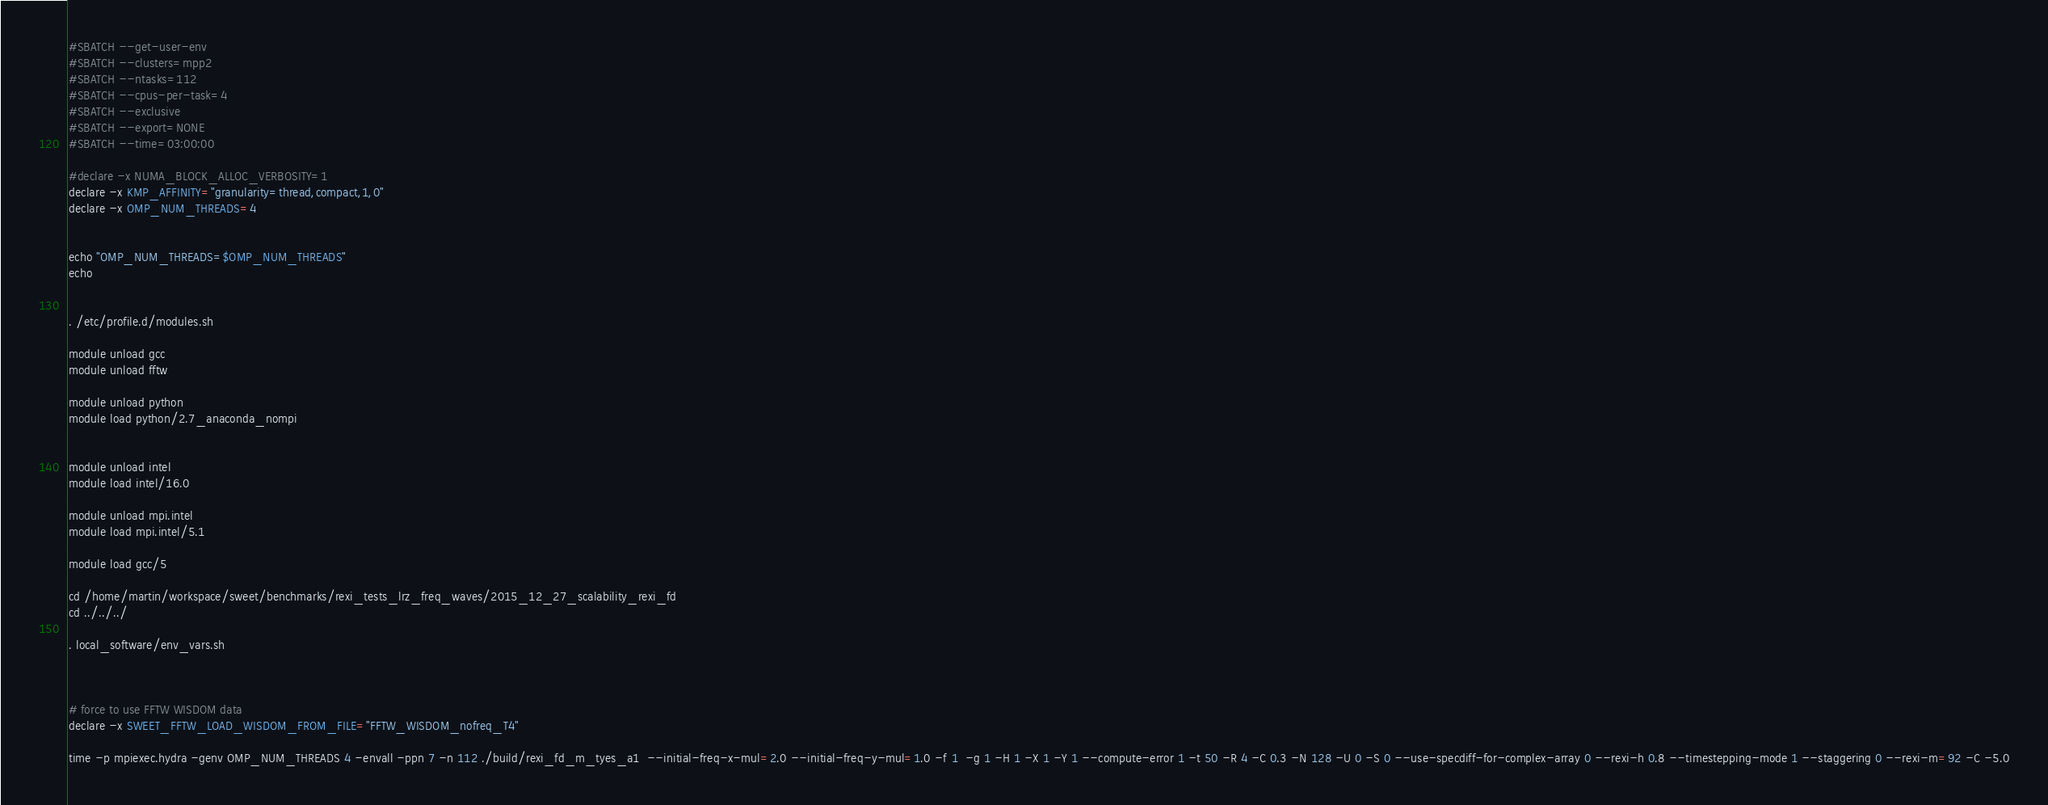Convert code to text. <code><loc_0><loc_0><loc_500><loc_500><_Bash_>#SBATCH --get-user-env
#SBATCH --clusters=mpp2
#SBATCH --ntasks=112
#SBATCH --cpus-per-task=4
#SBATCH --exclusive
#SBATCH --export=NONE
#SBATCH --time=03:00:00

#declare -x NUMA_BLOCK_ALLOC_VERBOSITY=1
declare -x KMP_AFFINITY="granularity=thread,compact,1,0"
declare -x OMP_NUM_THREADS=4


echo "OMP_NUM_THREADS=$OMP_NUM_THREADS"
echo


. /etc/profile.d/modules.sh

module unload gcc
module unload fftw

module unload python
module load python/2.7_anaconda_nompi


module unload intel
module load intel/16.0

module unload mpi.intel
module load mpi.intel/5.1

module load gcc/5

cd /home/martin/workspace/sweet/benchmarks/rexi_tests_lrz_freq_waves/2015_12_27_scalability_rexi_fd
cd ../../../

. local_software/env_vars.sh



# force to use FFTW WISDOM data
declare -x SWEET_FFTW_LOAD_WISDOM_FROM_FILE="FFTW_WISDOM_nofreq_T4"

time -p mpiexec.hydra -genv OMP_NUM_THREADS 4 -envall -ppn 7 -n 112 ./build/rexi_fd_m_tyes_a1  --initial-freq-x-mul=2.0 --initial-freq-y-mul=1.0 -f 1  -g 1 -H 1 -X 1 -Y 1 --compute-error 1 -t 50 -R 4 -C 0.3 -N 128 -U 0 -S 0 --use-specdiff-for-complex-array 0 --rexi-h 0.8 --timestepping-mode 1 --staggering 0 --rexi-m=92 -C -5.0

</code> 